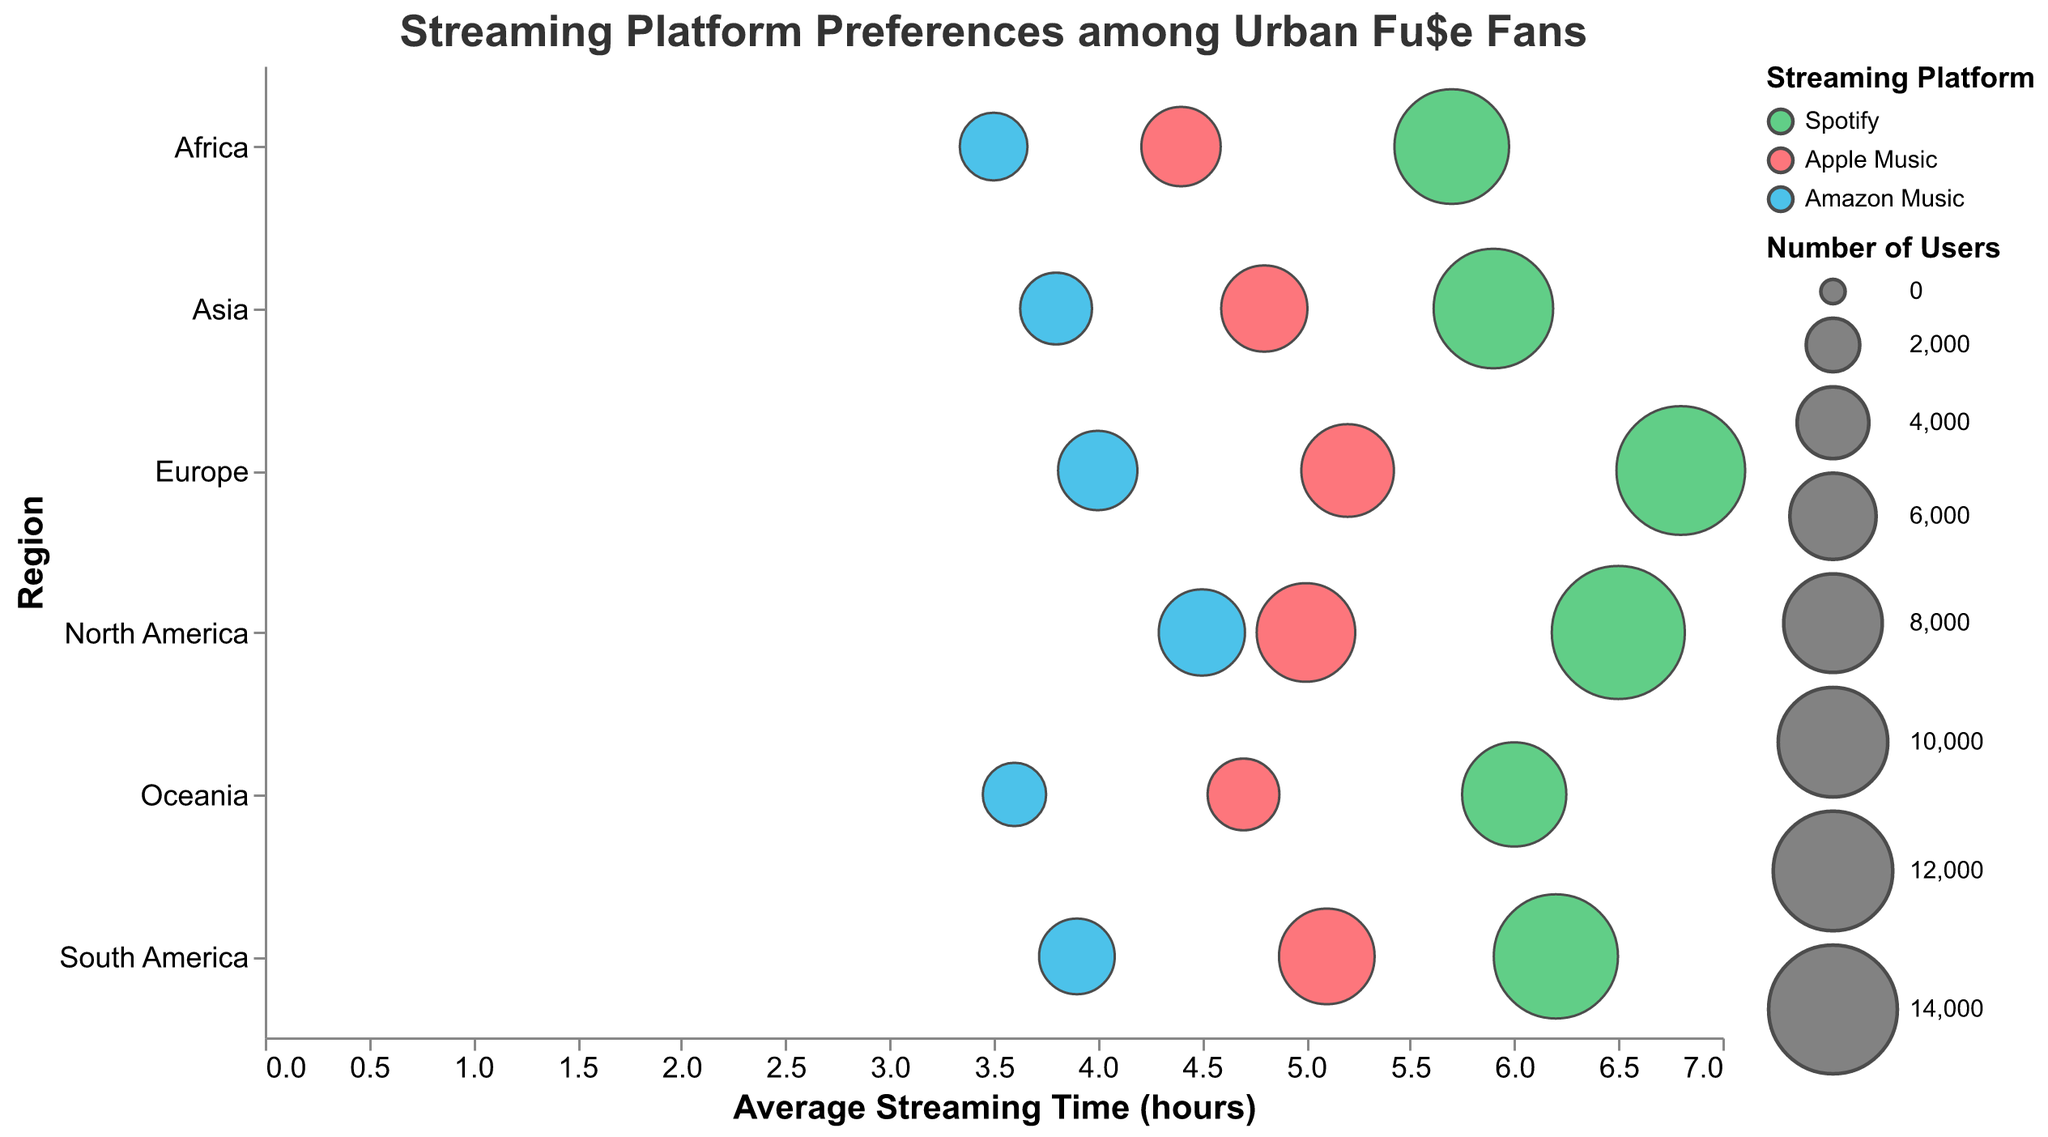How many regions are displayed in the figure? The figure has bubbles for six distinct regions. Each row on the y-axis corresponds to a different region.
Answer: 6 Which streaming platform has the highest average streaming time in North America? From the bubbles in the North America row, the highest x-value (representing average streaming time) belongs to Spotify with 6.5 hours.
Answer: Spotify What is the total number of users for Spotify in Europe? Refer to the bubble for Spotify in Europe. It indicates 14,000 users.
Answer: 14,000 Among Asia, South America, and Africa, which region has the highest average streaming time for Amazon Music? Check the x-values for Amazon Music in the Asia, South America, and Africa rows. Asia has the highest average streaming time for Amazon Music at 3.8 hours.
Answer: Asia What’s the difference in average streaming time between Spotify and Apple Music in Oceania? The x-values for Spotify and Apple Music in Oceania are 6.0 and 4.7 hours respectively. Subtract Apple Music's average from Spotify's average: 6.0 - 4.7 = 1.3 hours.
Answer: 1.3 hours Which streaming platform has the smallest bubble in Europe? The smallest bubble corresponds to the smallest number of users. For Europe, the smallest bubble belongs to Amazon Music with 5,000 users.
Answer: Amazon Music Across all regions, which streaming platform has the highest number of users? Look for the largest bubble across all rows. Spotify has the highest number of users, specifically in North America with 15,000 users.
Answer: Spotify What is the average streaming time for Apple Music in South America? Refer to the position of the bubble for Apple Music in South America on the x-axis, which shows an average streaming time of 5.1 hours.
Answer: 5.1 hours Compare the number of Amazon Music users in North America and Asia. Which has more, and by how much? Check the sizes of the bubbles for Amazon Music in North America and Asia. North America has 6,000 users, and Asia has 4,000 users. The difference is 2,000 users.
Answer: North America, 2,000 users 